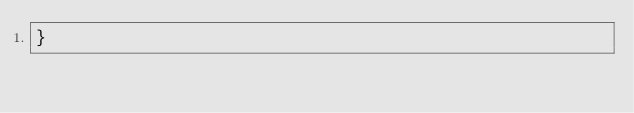Convert code to text. <code><loc_0><loc_0><loc_500><loc_500><_JavaScript_>}
</code> 